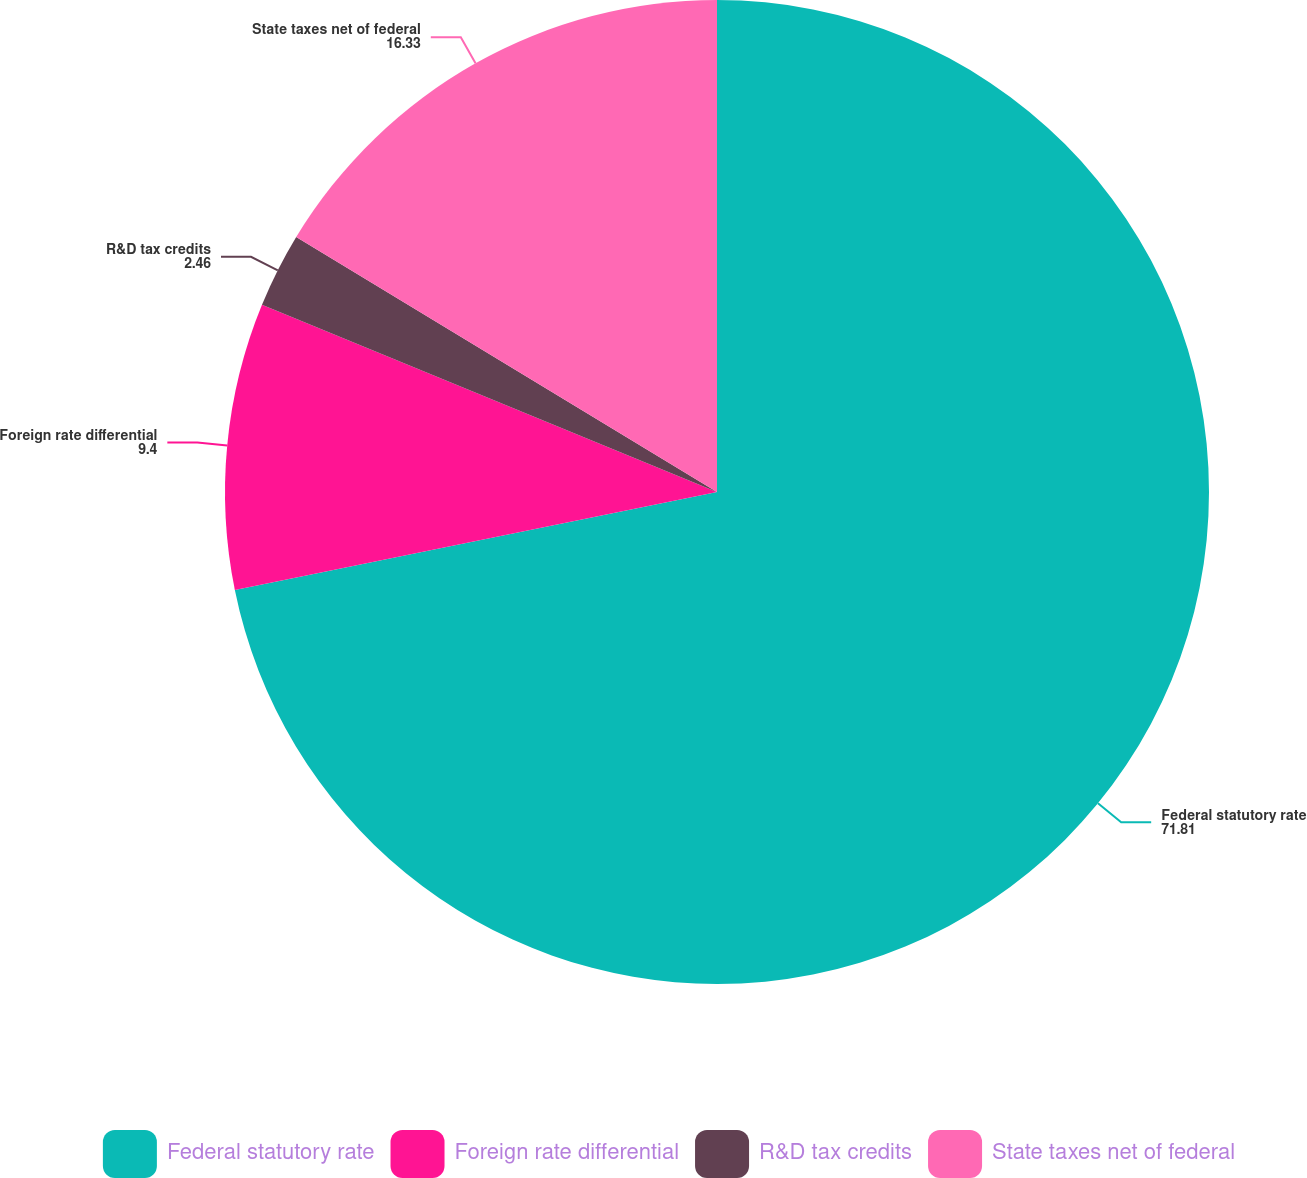<chart> <loc_0><loc_0><loc_500><loc_500><pie_chart><fcel>Federal statutory rate<fcel>Foreign rate differential<fcel>R&D tax credits<fcel>State taxes net of federal<nl><fcel>71.81%<fcel>9.4%<fcel>2.46%<fcel>16.33%<nl></chart> 